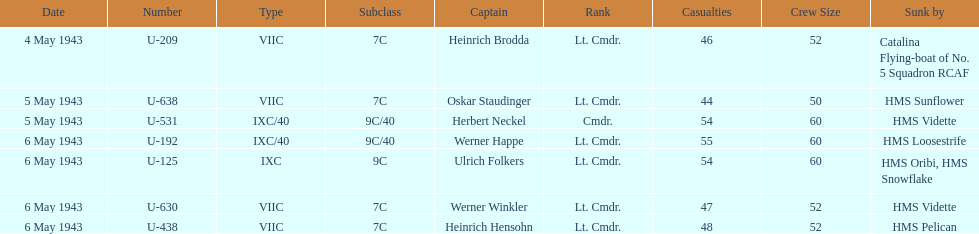Parse the full table. {'header': ['Date', 'Number', 'Type', 'Subclass', 'Captain', 'Rank', 'Casualties', 'Crew Size', 'Sunk by'], 'rows': [['4 May 1943', 'U-209', 'VIIC', '7C', 'Heinrich Brodda', 'Lt. Cmdr.', '46', '52', 'Catalina Flying-boat of No. 5 Squadron RCAF'], ['5 May 1943', 'U-638', 'VIIC', '7C', 'Oskar Staudinger', 'Lt. Cmdr.', '44', '50', 'HMS Sunflower'], ['5 May 1943', 'U-531', 'IXC/40', '9C/40', 'Herbert Neckel', 'Cmdr.', '54', '60', 'HMS Vidette'], ['6 May 1943', 'U-192', 'IXC/40', '9C/40', 'Werner Happe', 'Lt. Cmdr.', '55', '60', 'HMS Loosestrife'], ['6 May 1943', 'U-125', 'IXC', '9C', 'Ulrich Folkers', 'Lt. Cmdr.', '54', '60', 'HMS Oribi, HMS Snowflake'], ['6 May 1943', 'U-630', 'VIIC', '7C', 'Werner Winkler', 'Lt. Cmdr.', '47', '52', 'HMS Vidette'], ['6 May 1943', 'U-438', 'VIIC', '7C', 'Heinrich Hensohn', 'Lt. Cmdr.', '48', '52', 'HMS Pelican']]} Which u-boat was the first to sink U-209. 